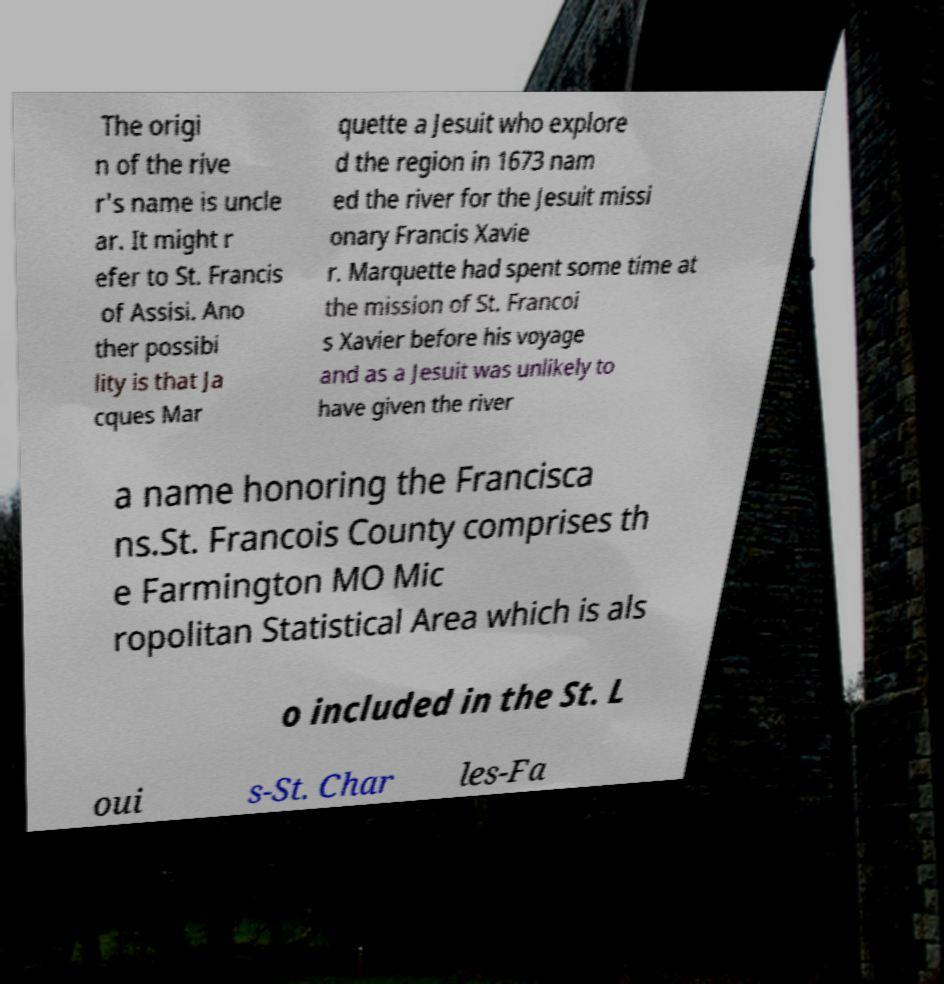For documentation purposes, I need the text within this image transcribed. Could you provide that? The origi n of the rive r's name is uncle ar. It might r efer to St. Francis of Assisi. Ano ther possibi lity is that Ja cques Mar quette a Jesuit who explore d the region in 1673 nam ed the river for the Jesuit missi onary Francis Xavie r. Marquette had spent some time at the mission of St. Francoi s Xavier before his voyage and as a Jesuit was unlikely to have given the river a name honoring the Francisca ns.St. Francois County comprises th e Farmington MO Mic ropolitan Statistical Area which is als o included in the St. L oui s-St. Char les-Fa 